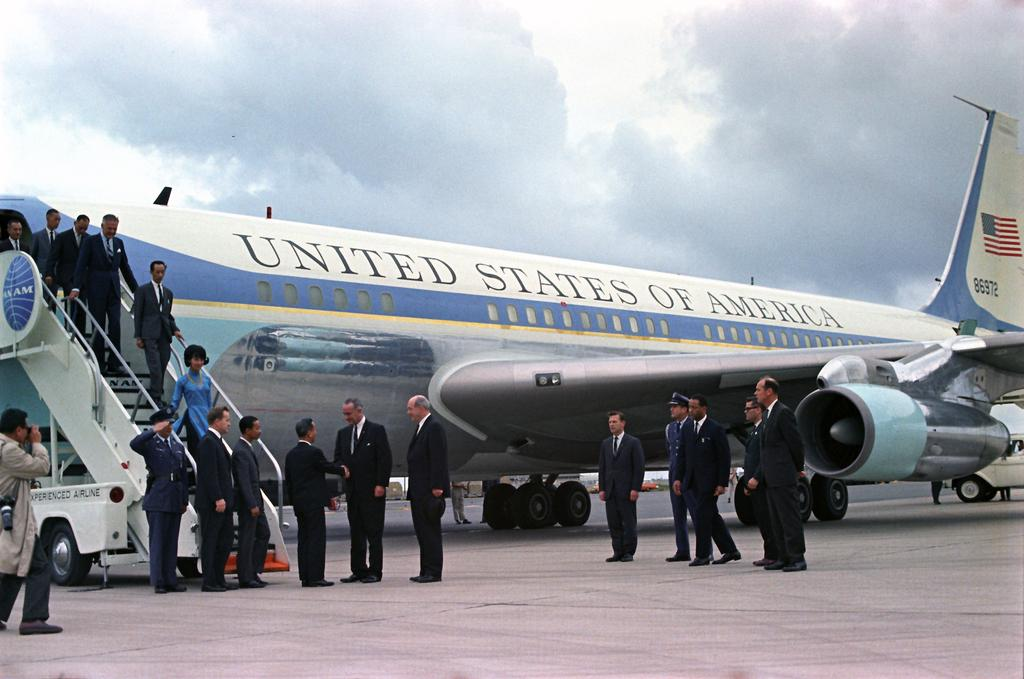<image>
Give a short and clear explanation of the subsequent image. An airplane that says United States of America has numerous people in front of it. 